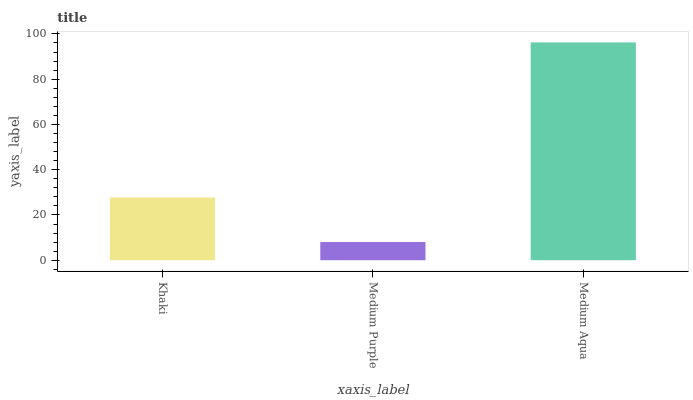Is Medium Aqua the minimum?
Answer yes or no. No. Is Medium Purple the maximum?
Answer yes or no. No. Is Medium Aqua greater than Medium Purple?
Answer yes or no. Yes. Is Medium Purple less than Medium Aqua?
Answer yes or no. Yes. Is Medium Purple greater than Medium Aqua?
Answer yes or no. No. Is Medium Aqua less than Medium Purple?
Answer yes or no. No. Is Khaki the high median?
Answer yes or no. Yes. Is Khaki the low median?
Answer yes or no. Yes. Is Medium Purple the high median?
Answer yes or no. No. Is Medium Purple the low median?
Answer yes or no. No. 